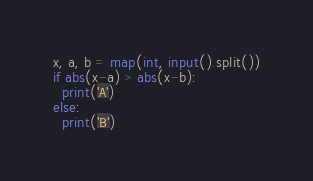<code> <loc_0><loc_0><loc_500><loc_500><_Python_>x, a, b = map(int, input().split())
if abs(x-a) > abs(x-b):
  print('A')
else:
  print('B')</code> 